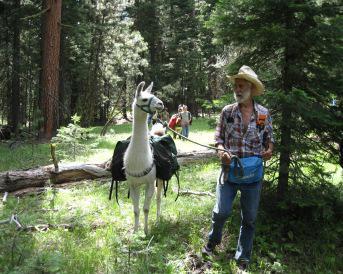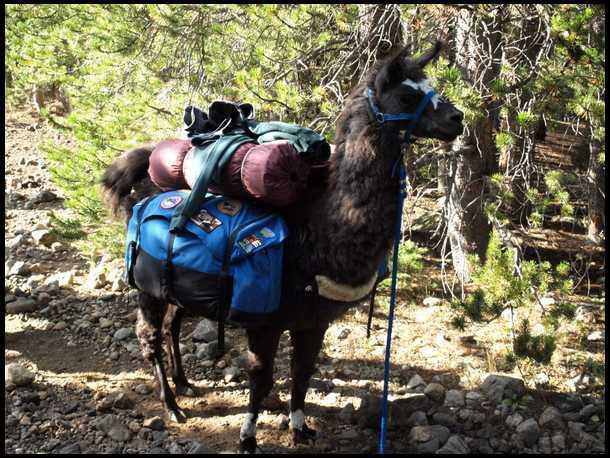The first image is the image on the left, the second image is the image on the right. Considering the images on both sides, is "At least one person can be seen riding a llama." valid? Answer yes or no. No. The first image is the image on the left, the second image is the image on the right. Analyze the images presented: Is the assertion "There are humans riding the llamas." valid? Answer yes or no. No. 